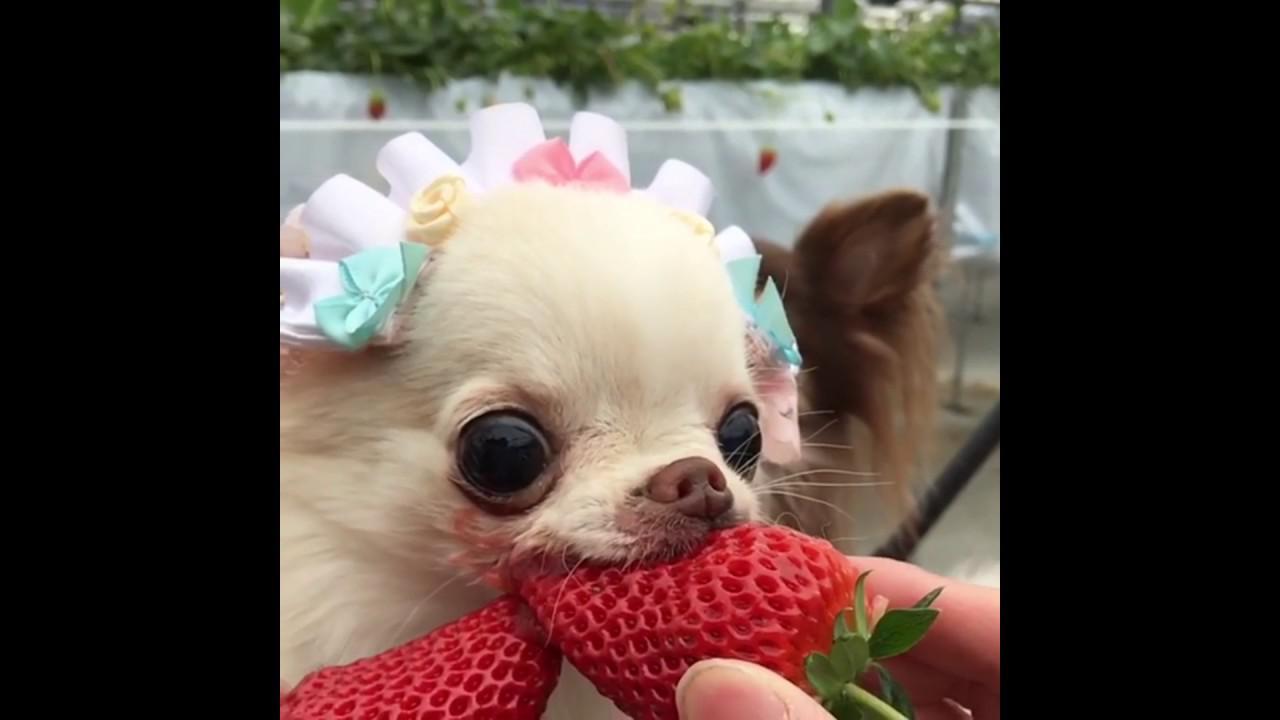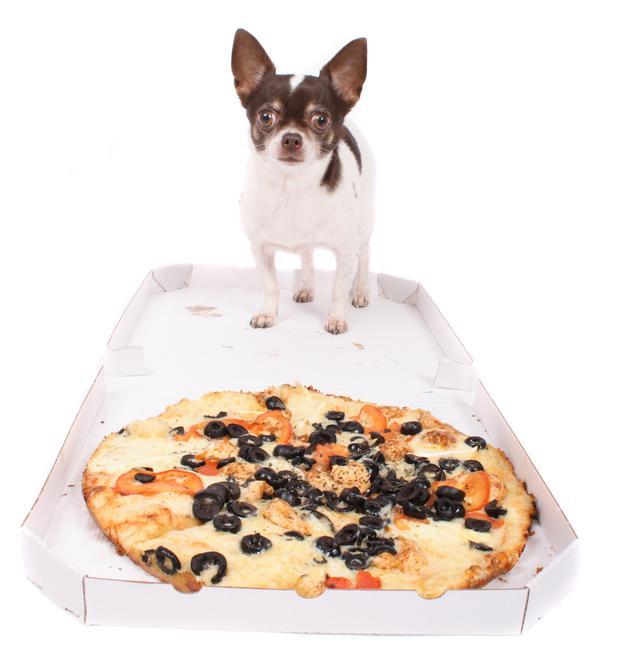The first image is the image on the left, the second image is the image on the right. Considering the images on both sides, is "One dog is eating strawberries." valid? Answer yes or no. Yes. The first image is the image on the left, the second image is the image on the right. Considering the images on both sides, is "There is a dog standing beside a white plate full of food on a patterned table in one of the images." valid? Answer yes or no. No. 